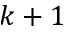Convert formula to latex. <formula><loc_0><loc_0><loc_500><loc_500>k + 1</formula> 